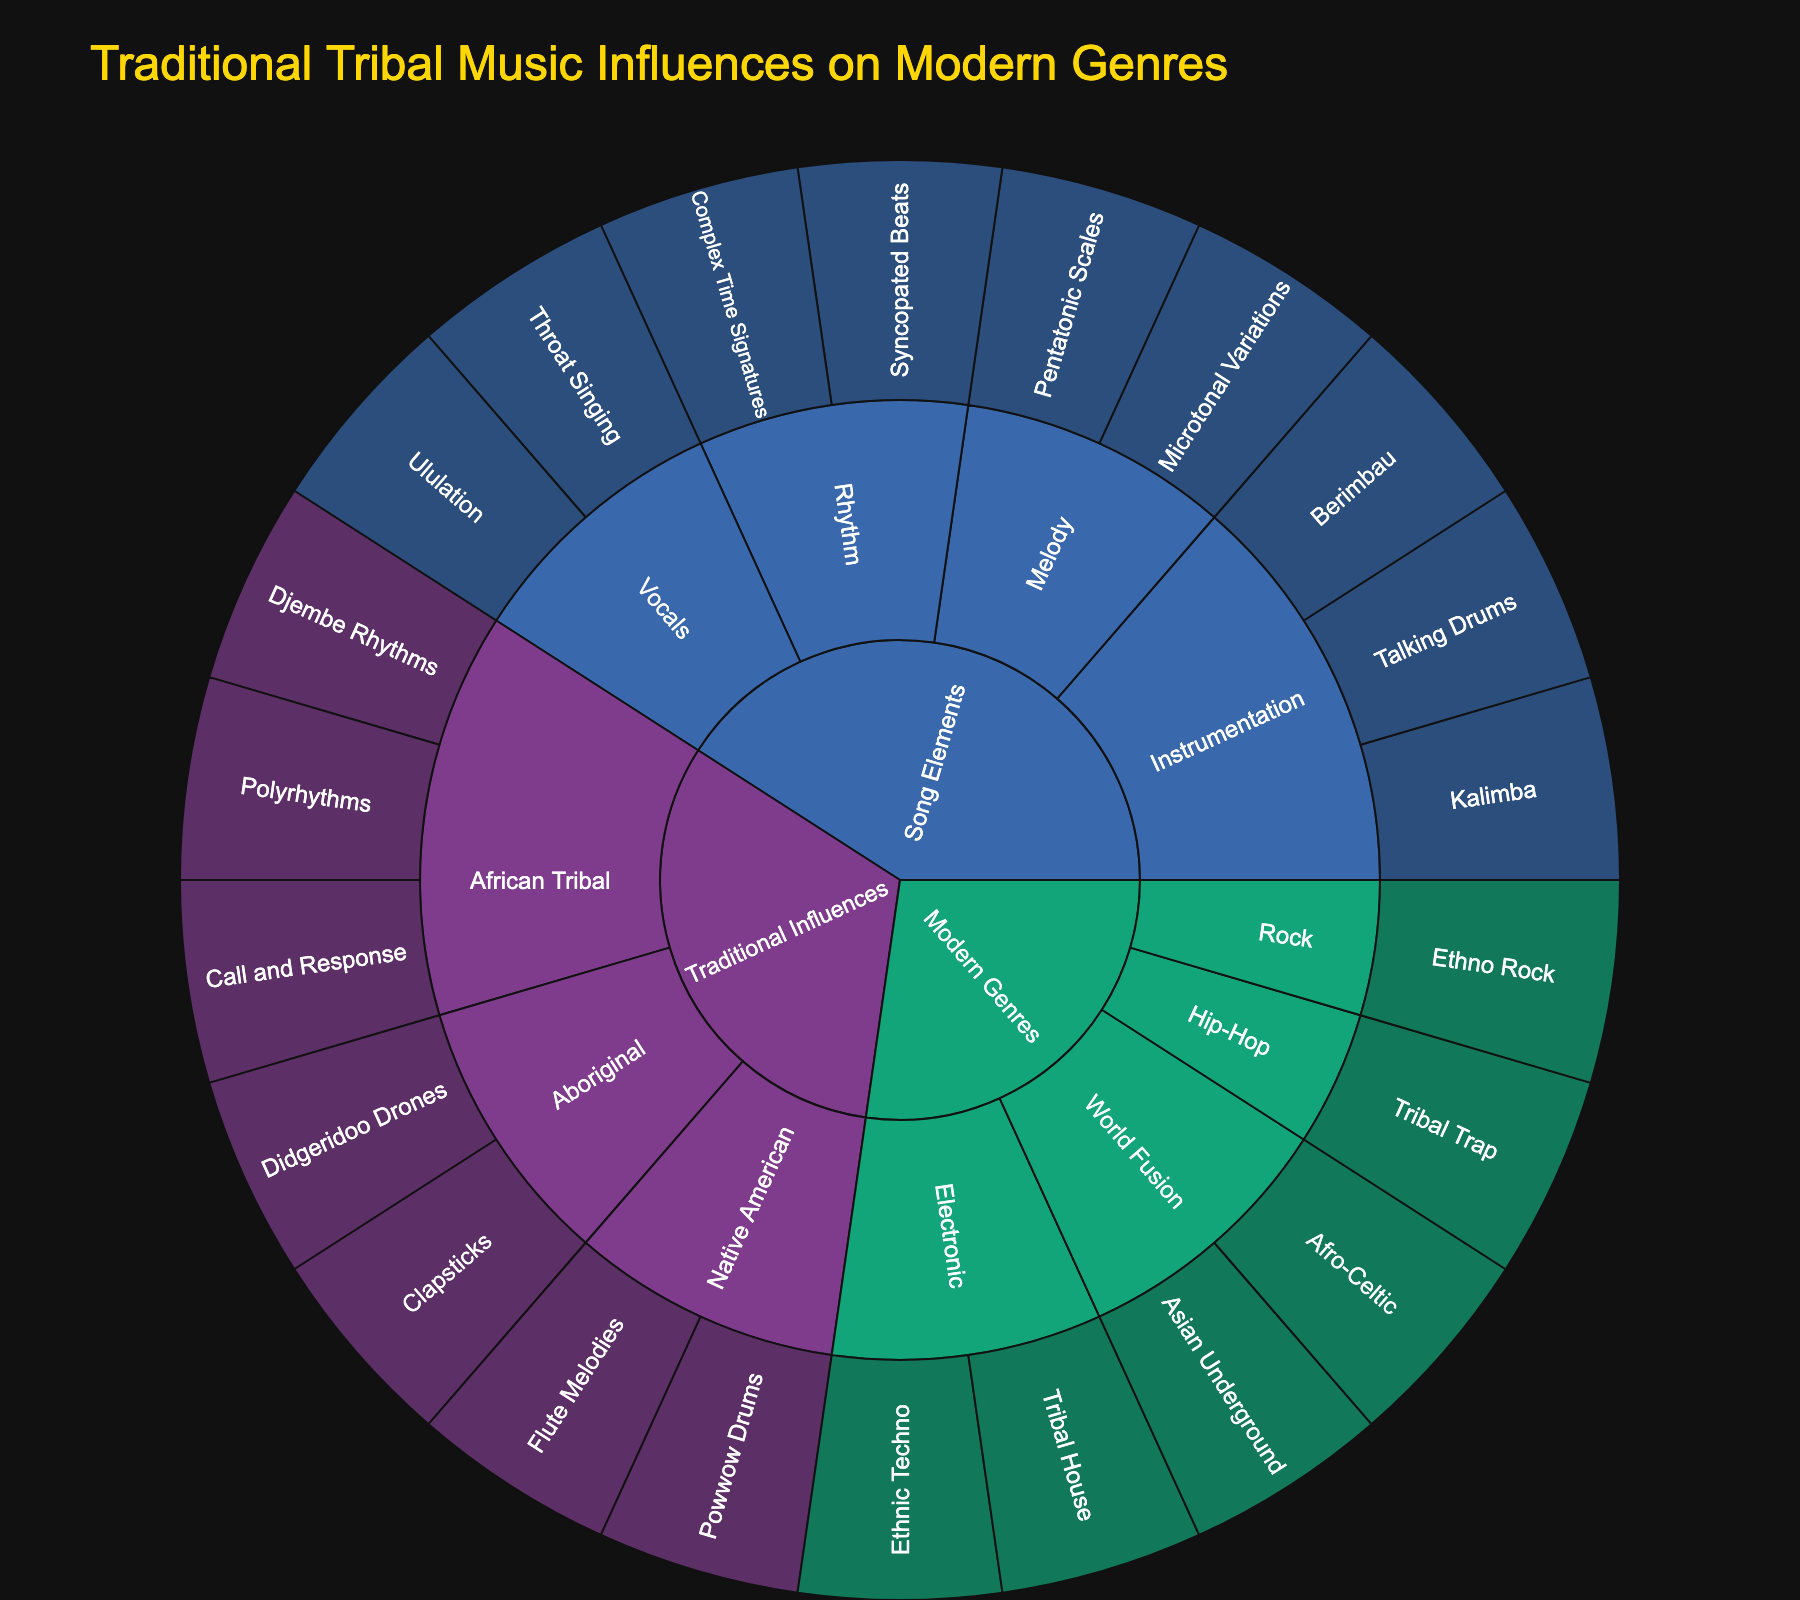What is the title of this sunburst chart? The title is prominently displayed at the top of the chart.
Answer: Traditional Tribal Music Influences on Modern Genres How many main categories are represented in the chart? The inner ring of the sunburst chart shows the main categories. Counting the distinct segments in the inner ring gives us the number of main categories.
Answer: 3 Which subgenre in the "Traditional Influences" category has the greatest number of elements? Follow the segments under "Traditional Influences" and count the number of elements for each subgenre. Compare the counts to find the one with the most elements.
Answer: African Tribal What are the elements found under the "Native American" subgenre? Locate the "Native American" subgenre within the "Traditional Influences" category and look at the elements branching from it.
Answer: Flute Melodies, Powwow Drums Which category includes "Tribal Trap"? Locate the element "Tribal Trap" in the chart and trace it back to its parent categories.
Answer: Modern Genres What subgenres in the "Modern Genres" category have the fewest elements? Identify all subgenres under "Modern Genres", count the elements in each, and find the subgenre(s) with the minimum count.
Answer: Hip-Hop, Rock (both have 1 element) How many elements are listed under the "Song Elements" category? Follow the segments under "Song Elements" and count the number of elements.
Answer: 9 Which subgenres are influenced by "African Tribal" rhythms? Find "African Tribal" under "Traditional Influences" and identify its elements, then track how these elements influence the subgenres. Note: In the given data, subgenres directly linked to "traditional influences" is shown.
Answer: This question is illogical based on the given data structure; rephrase to understand African influences in modern genres/elements instead Which subgenre includes "Didgeridoo Drones"? Locate "Didgeridoo Drones" in the chart and trace it back to its subgenre.
Answer: Aboriginal What are the rhythmic elements present in the "Song Elements" category? Identify segments branching under the "Song Elements" category and specifically look for those labeled with rhythmic elements.
Answer: Syncopated Beats, Complex Time Signatures 